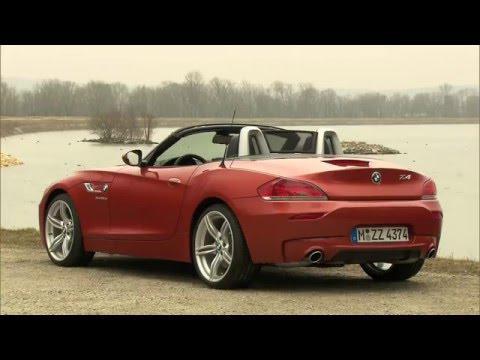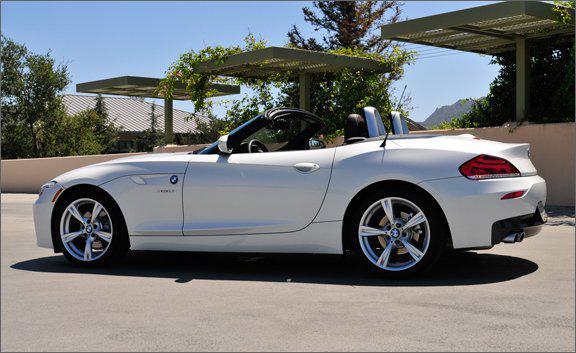The first image is the image on the left, the second image is the image on the right. Given the left and right images, does the statement "One of the cars is red." hold true? Answer yes or no. Yes. The first image is the image on the left, the second image is the image on the right. Analyze the images presented: Is the assertion "A body of water is in the background of a convertible in one of the images." valid? Answer yes or no. Yes. 